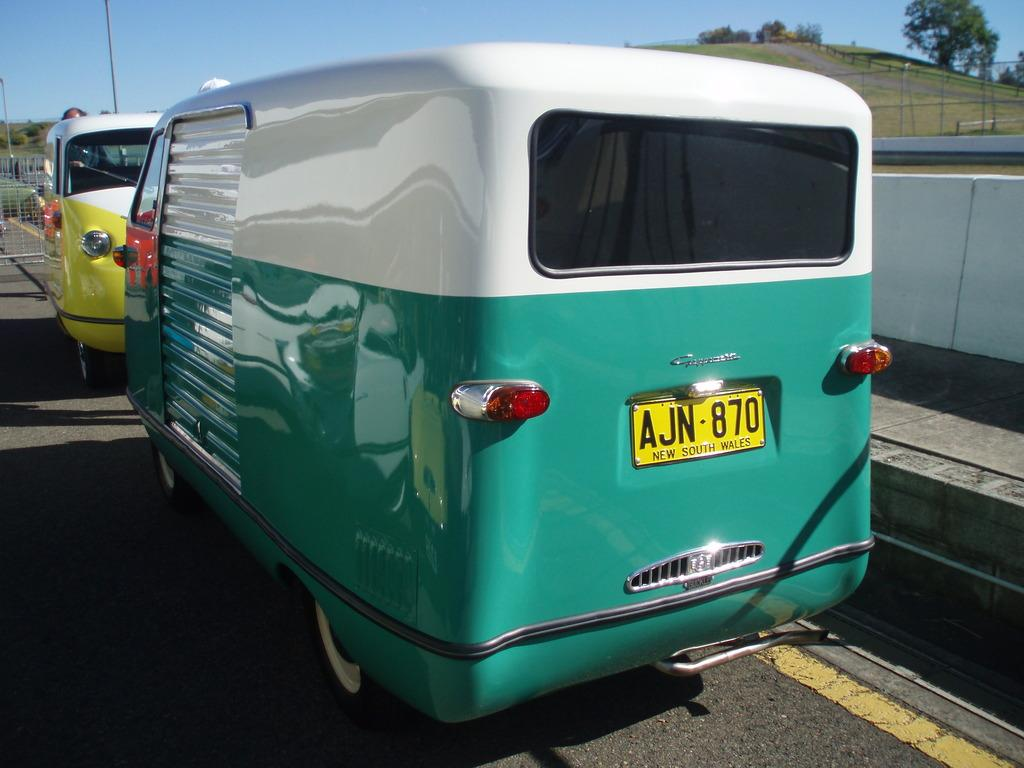<image>
Summarize the visual content of the image. A white and green old fashioned van has a yellow license plate that says New South Wales. 